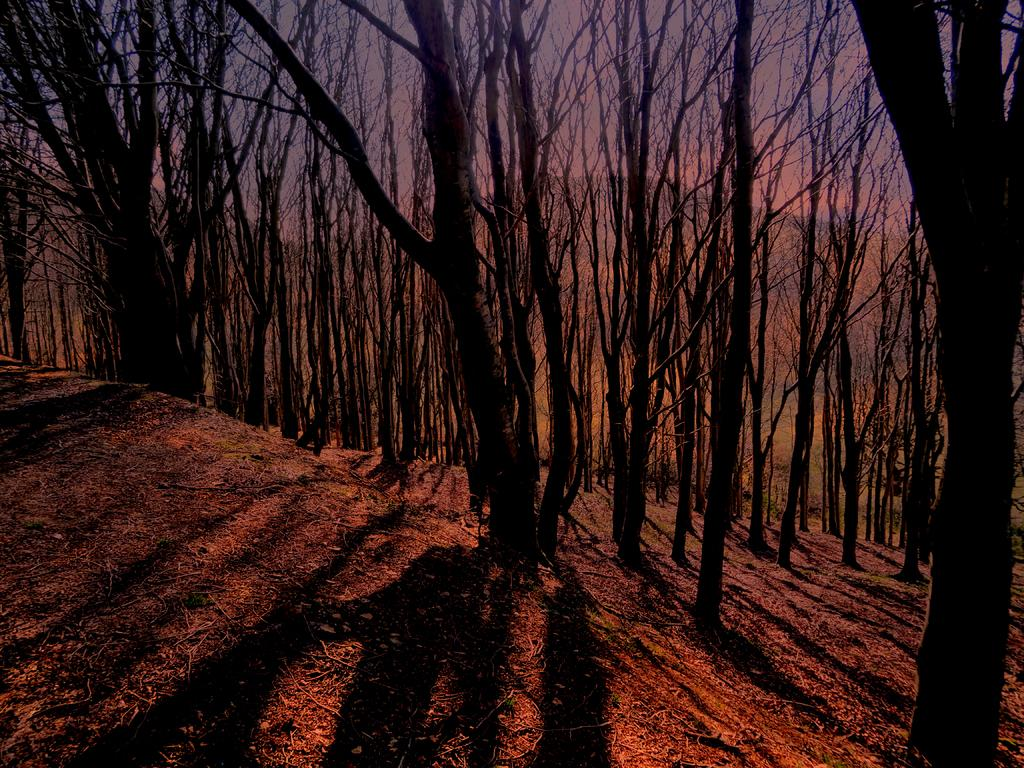What type of natural material can be seen in the image? There are shredded leaves and twigs in the image. What type of vegetation is present in the image? There are trees in the image. What type of geographical feature can be seen in the image? There are hills in the image. What is visible in the sky in the image? The sky is visible in the image. What type of government is depicted in the image? There is no government depicted in the image; it features shredded leaves, twigs, trees, hills, and the sky. What scientific theory can be observed in the image? There is no scientific theory present in the image; it features shredded leaves, twigs, trees, hills, and the sky. 